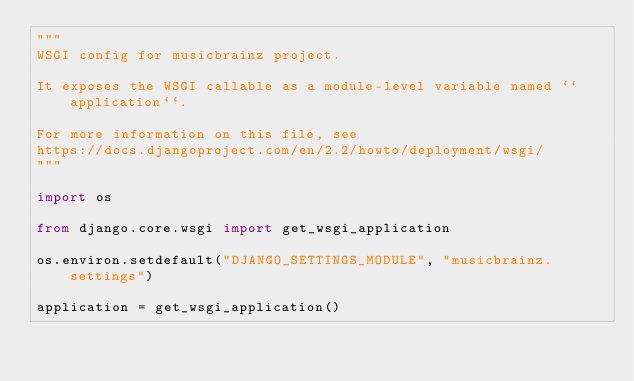Convert code to text. <code><loc_0><loc_0><loc_500><loc_500><_Python_>"""
WSGI config for musicbrainz project.

It exposes the WSGI callable as a module-level variable named ``application``.

For more information on this file, see
https://docs.djangoproject.com/en/2.2/howto/deployment/wsgi/
"""

import os

from django.core.wsgi import get_wsgi_application

os.environ.setdefault("DJANGO_SETTINGS_MODULE", "musicbrainz.settings")

application = get_wsgi_application()
</code> 